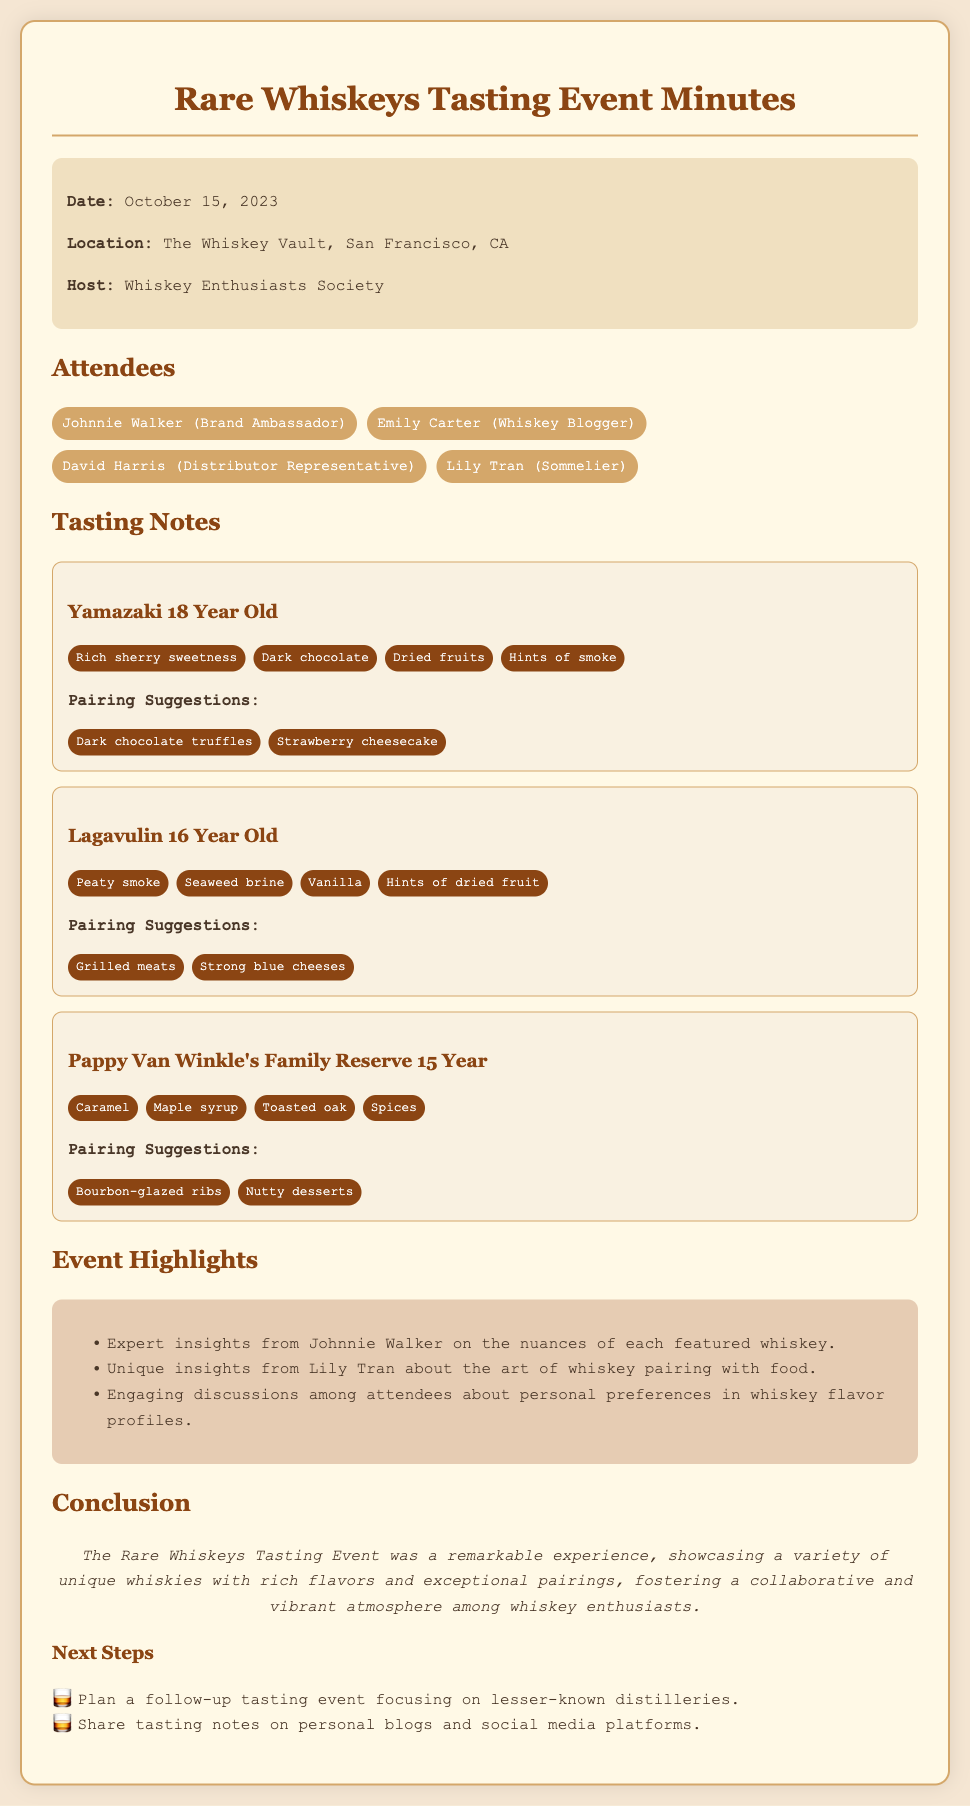what is the date of the event? The date of the event is indicated in the document as October 15, 2023.
Answer: October 15, 2023 where was the tasting event held? The location of the event is specified in the document as The Whiskey Vault, San Francisco, CA.
Answer: The Whiskey Vault, San Francisco, CA who hosted the event? The host of the event is mentioned as the Whiskey Enthusiasts Society.
Answer: Whiskey Enthusiasts Society what is one of the flavors noted for Yamazaki 18 Year Old? The document lists specific flavors for Yamazaki 18 Year Old, one of which is rich sherry sweetness.
Answer: Rich sherry sweetness which whiskey had pairing suggestions of grilled meats? The pairing suggestions for this whiskey are provided in the document under Lagavulin 16 Year Old.
Answer: Lagavulin 16 Year Old what was a highlight of the event? The document notes engaging discussions among attendees about personal preferences in whiskey flavor profiles as a highlight.
Answer: Engaging discussions among attendees which whiskey is associated with caramel and maple syrup flavors? The flavors are described in connection with Pappy Van Winkle's Family Reserve 15 Year.
Answer: Pappy Van Winkle's Family Reserve 15 Year how many attendees were there at the event? The document lists four attendees present at the event.
Answer: Four 